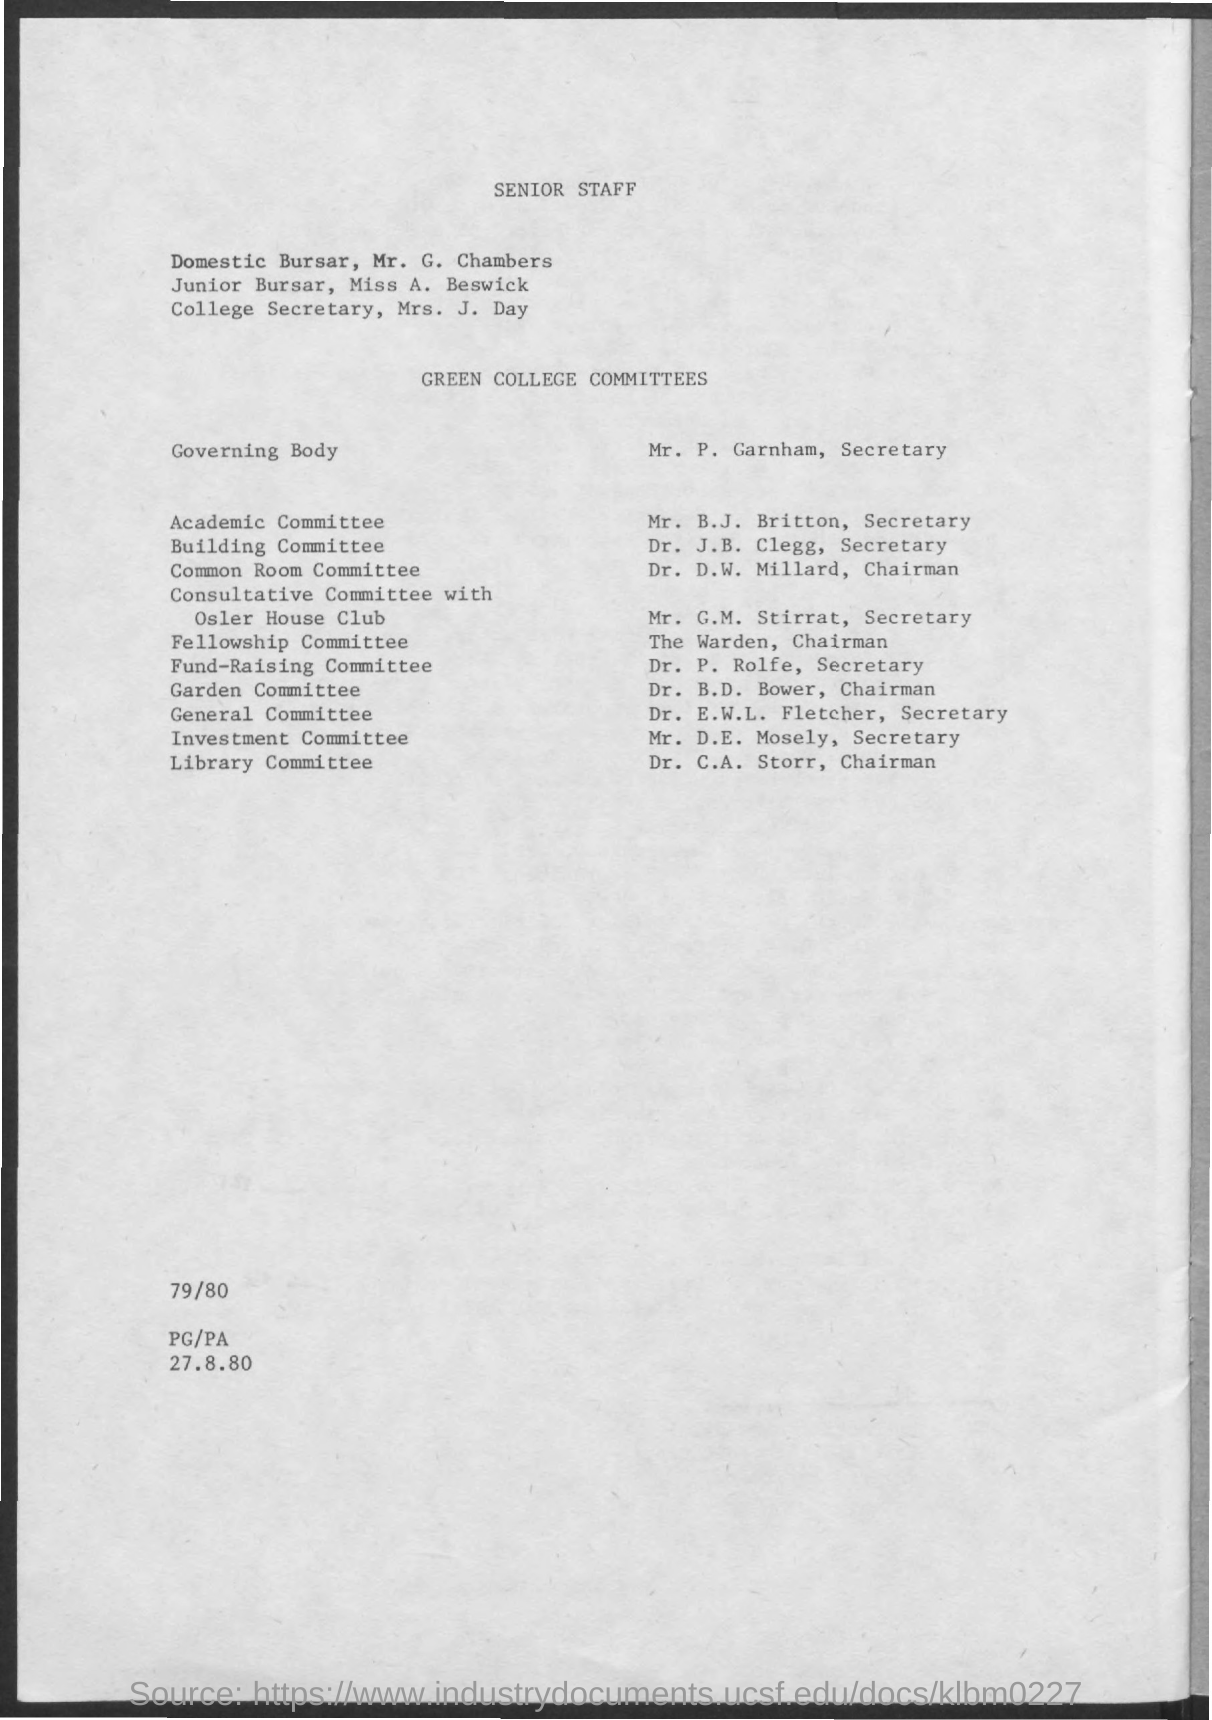What is the name of the junior bursar ?
Offer a terse response. Miss A. Beswick. Who is the secretary of academic committee ?
Your response must be concise. Mr. B.J. Britton. Who is the chairman of common room committee ?
Offer a terse response. Dr. D.W. Millard. Who is the secretary of building committee ?
Make the answer very short. Dr. J.B. Clegg. Who is the chairman of fellowship committee ?
Provide a succinct answer. The Warden. Dr. B.D. Bower belongs to which committee ?
Provide a short and direct response. Garden committee. Who is the chairman of library committee ?
Your answer should be compact. Dr. C.A. Storr. Mr. D.E. Mosely belongs to which committee ?
Keep it short and to the point. Investment committee. 